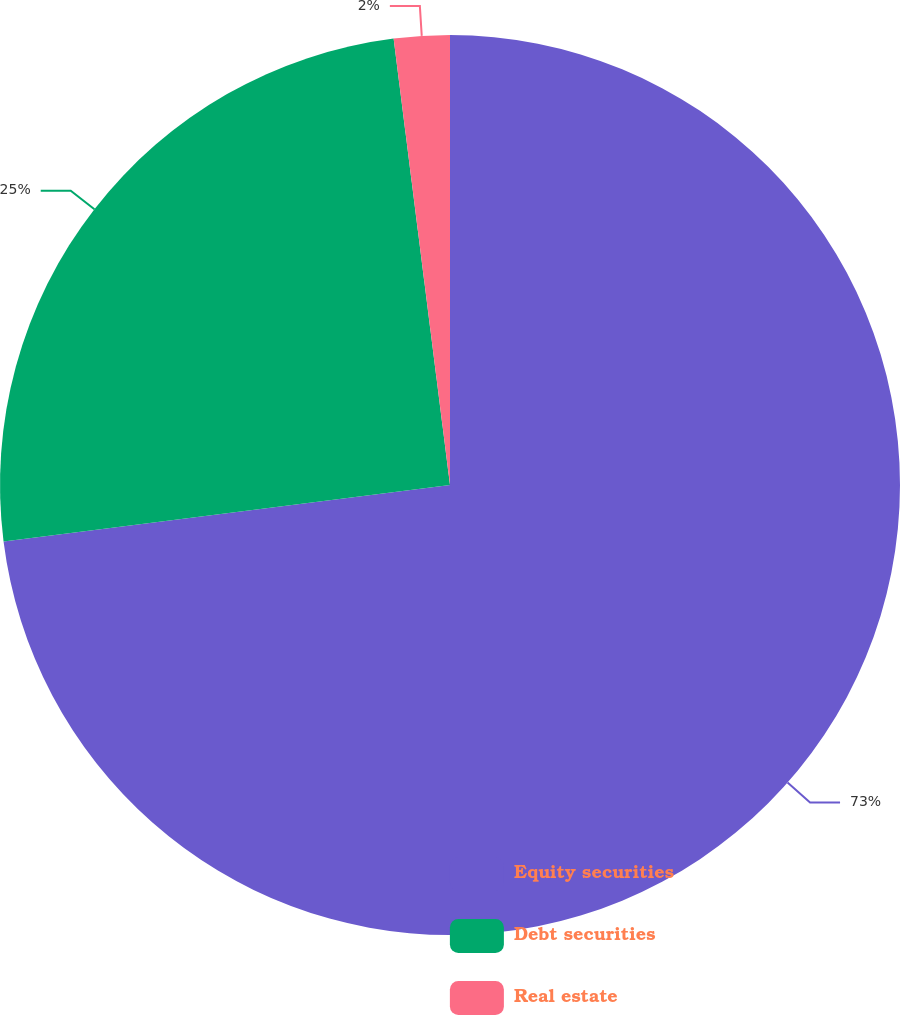Convert chart to OTSL. <chart><loc_0><loc_0><loc_500><loc_500><pie_chart><fcel>Equity securities<fcel>Debt securities<fcel>Real estate<nl><fcel>73.0%<fcel>25.0%<fcel>2.0%<nl></chart> 